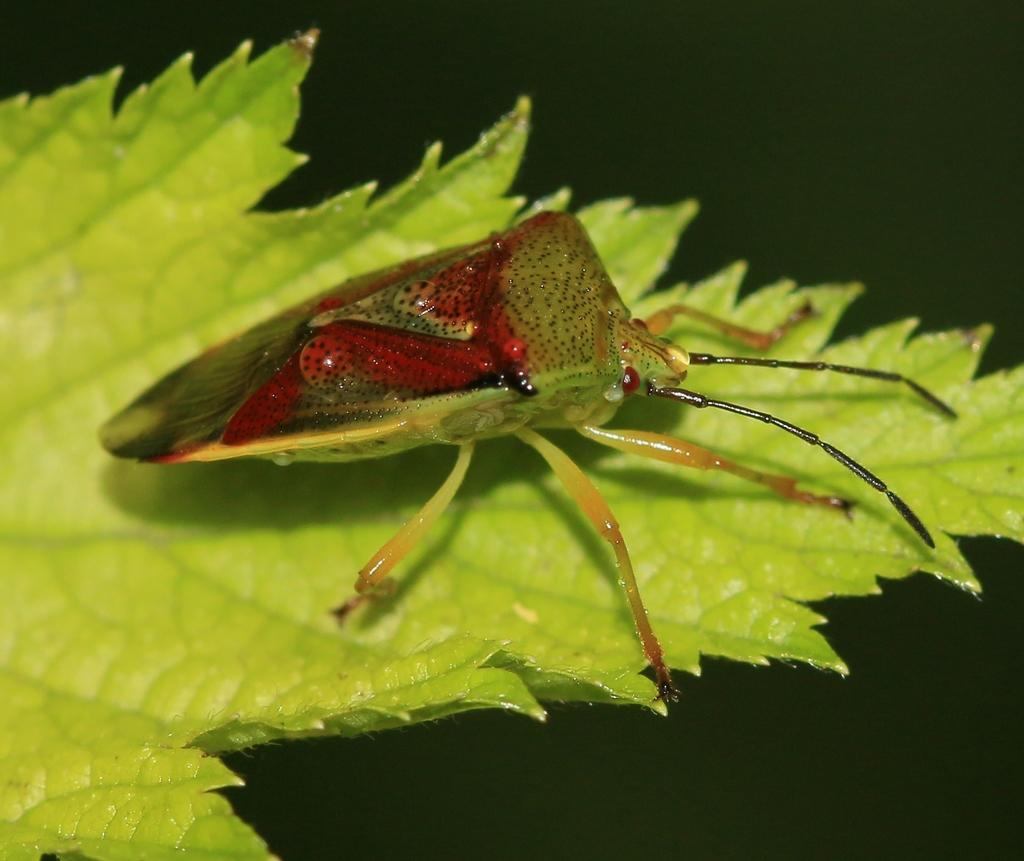What is present on the green leaf in the image? There is an insect on the green leaf in the image. What can be inferred about the environment of the insect? The insect is on a green leaf, which suggests it might be in a natural setting. How would you describe the overall lighting in the image? The background of the image appears to be a bit dark. What type of cloth is draped over the desk in the image? There is no desk or cloth present in the image; it features an insect on a green leaf with a dark background. 